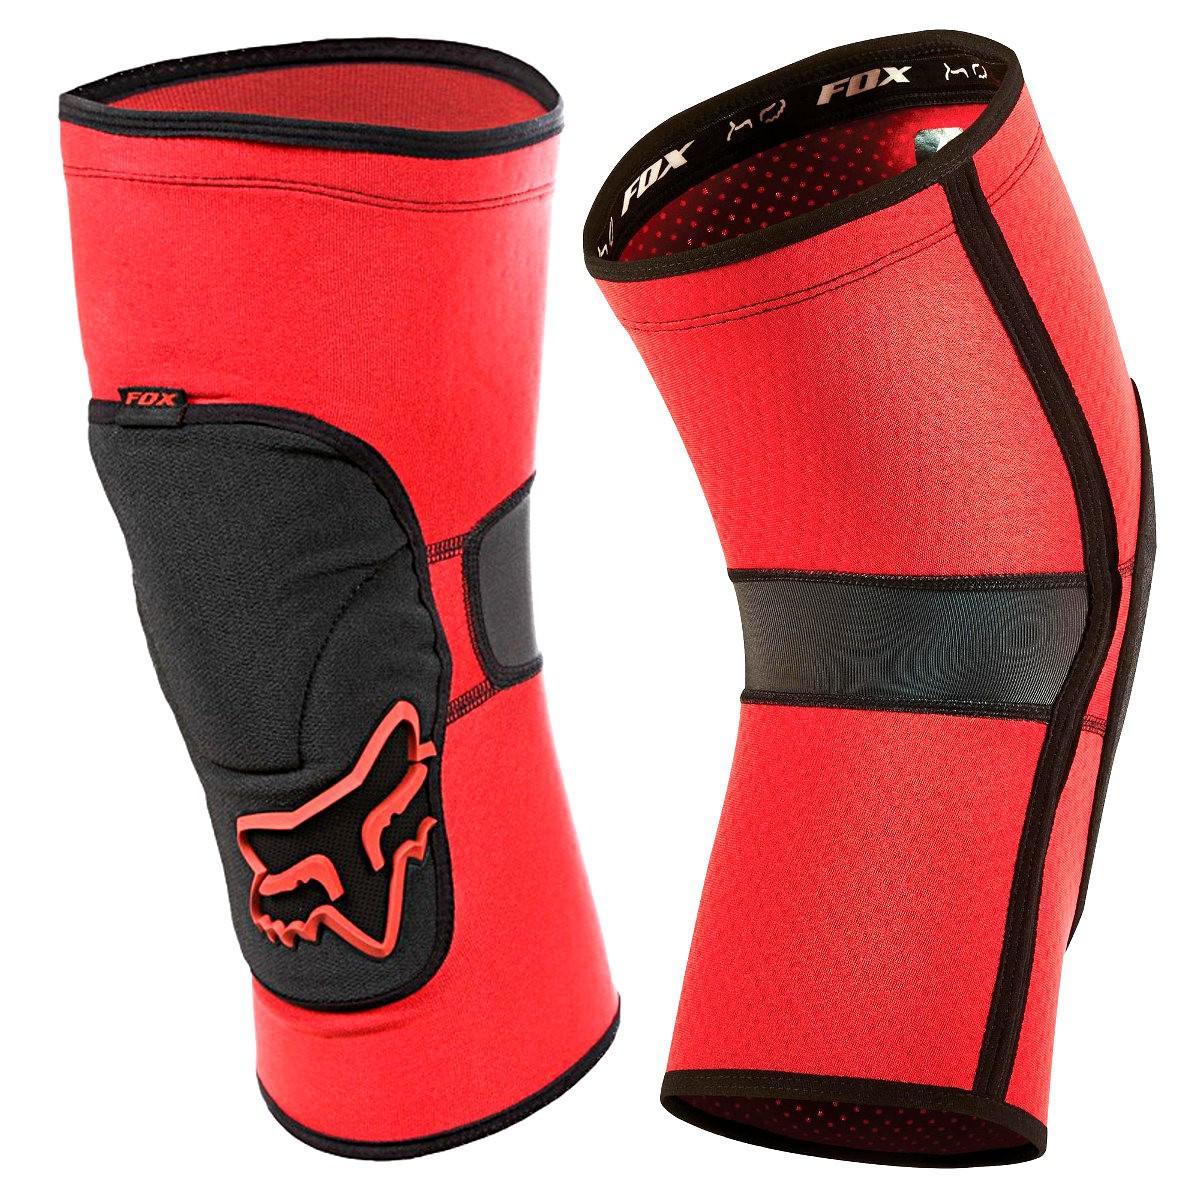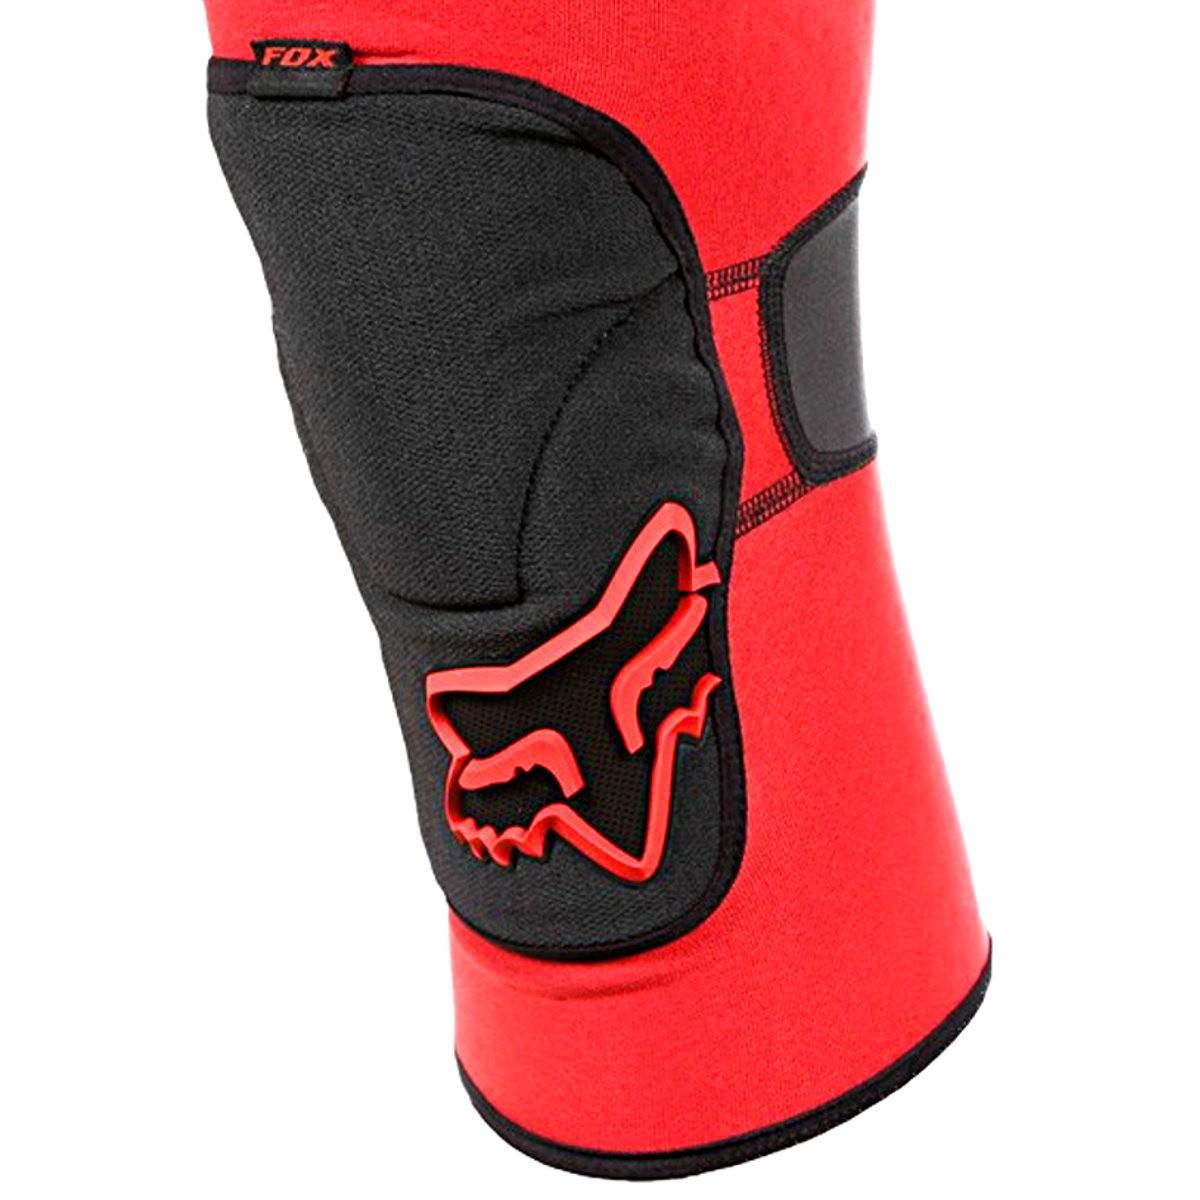The first image is the image on the left, the second image is the image on the right. For the images shown, is this caption "There are two knee pads that are primarily black in color" true? Answer yes or no. No. 